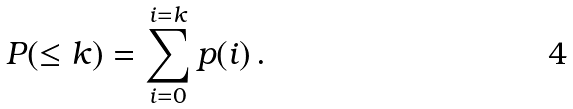Convert formula to latex. <formula><loc_0><loc_0><loc_500><loc_500>P ( \leq k ) = \sum _ { i = 0 } ^ { i = k } p ( i ) \, .</formula> 